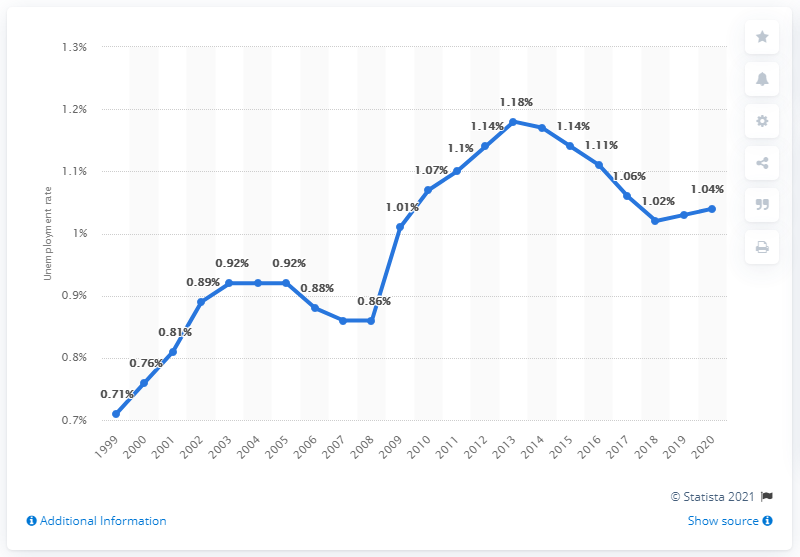Draw attention to some important aspects in this diagram. In 2020, the unemployment rate in Rwanda was 1.04%. 